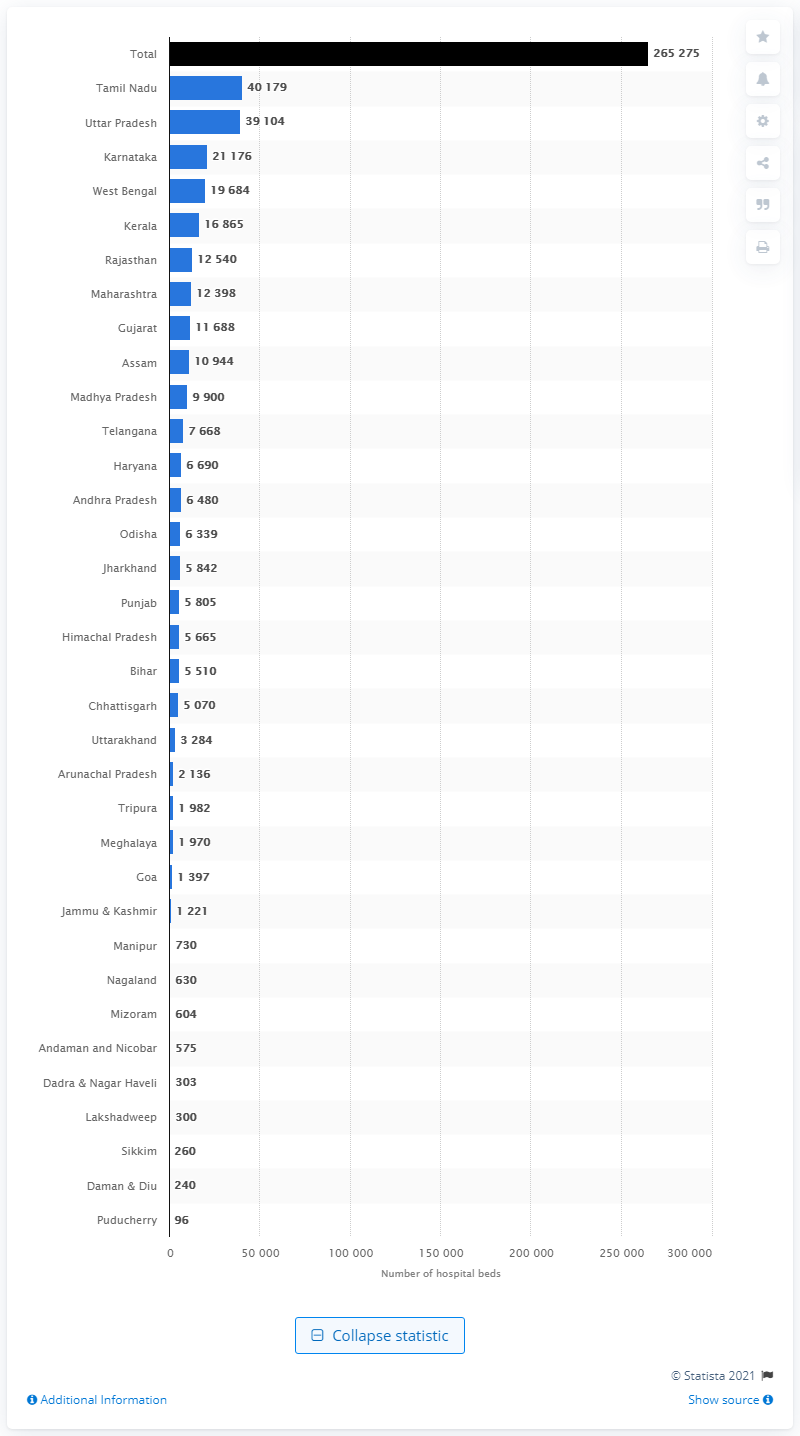Indicate a few pertinent items in this graphic. In 2018, Tamil Nadu had a total of 40,179 hospital beds. Tamil Nadu is a union territory that is composed of the union territory of Puducherry. 